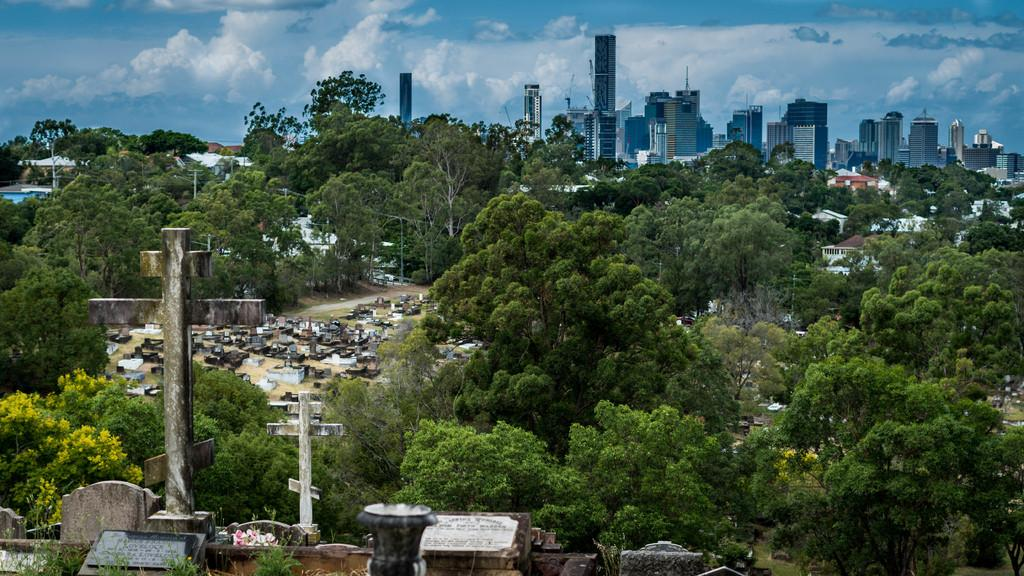What type of natural elements can be seen in the image? There are trees, plants, and grass visible in the image. What type of man-made structures are present in the image? There are houses, buildings, and poles in the image. What is visible at the top of the image? The sky is visible at the top of the image. What is the condition of the sky in the image? The sky is cloudy in the image. What type of fan can be seen in the image? There is no fan present in the image. What material is the brass used for in the image? There is no brass present in the image. 